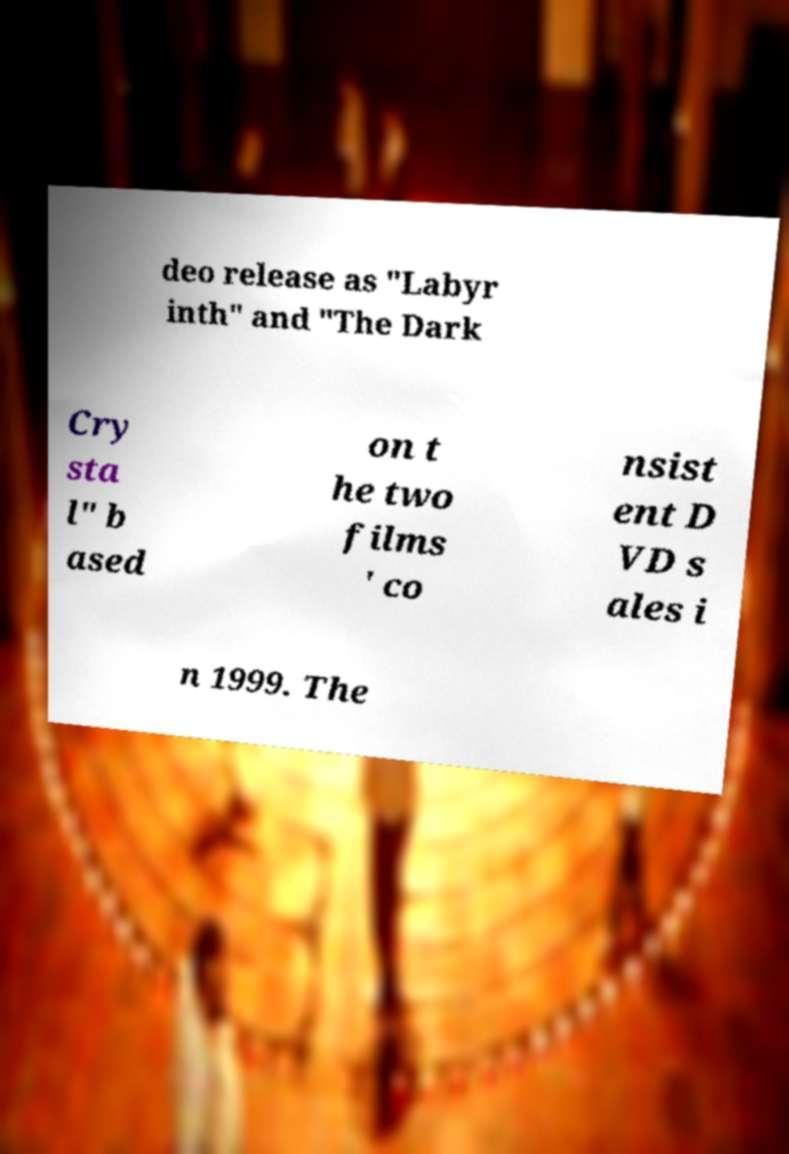Can you read and provide the text displayed in the image?This photo seems to have some interesting text. Can you extract and type it out for me? deo release as "Labyr inth" and "The Dark Cry sta l" b ased on t he two films ' co nsist ent D VD s ales i n 1999. The 